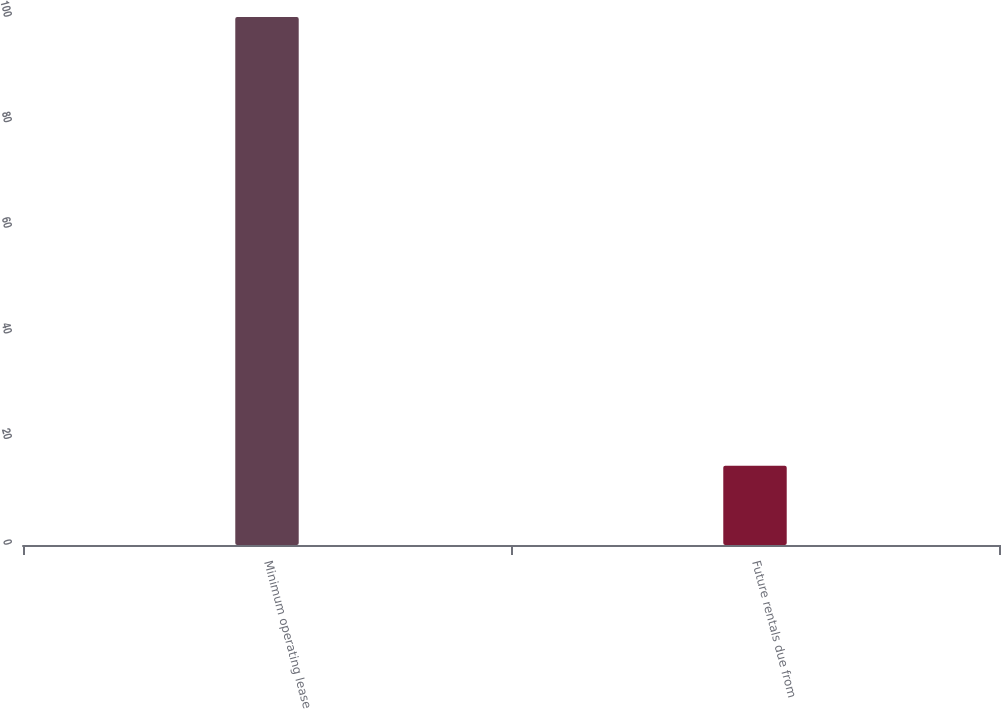Convert chart. <chart><loc_0><loc_0><loc_500><loc_500><bar_chart><fcel>Minimum operating lease<fcel>Future rentals due from<nl><fcel>100<fcel>15<nl></chart> 